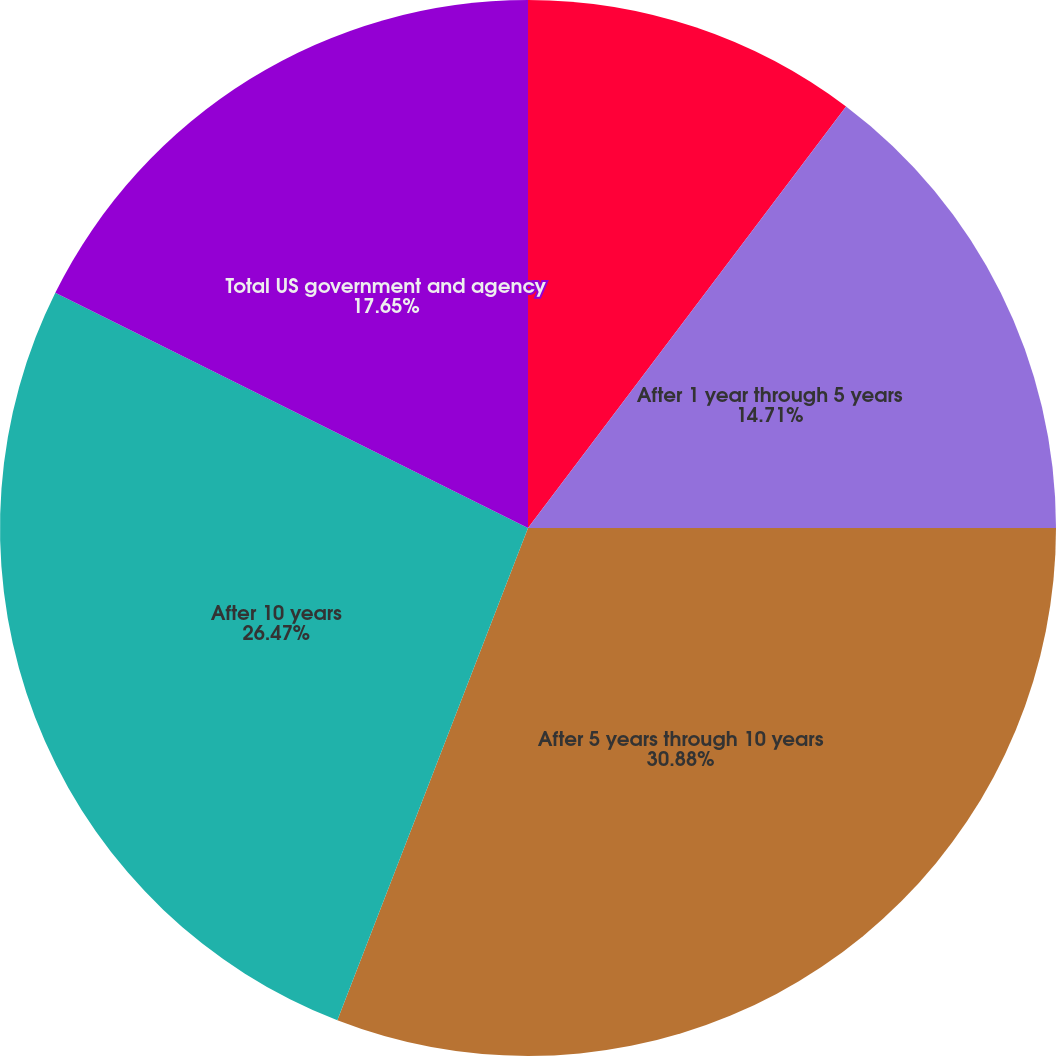Convert chart. <chart><loc_0><loc_0><loc_500><loc_500><pie_chart><fcel>Due within 1 year<fcel>After 1 year through 5 years<fcel>After 5 years through 10 years<fcel>After 10 years<fcel>Total US government and agency<nl><fcel>10.29%<fcel>14.71%<fcel>30.88%<fcel>26.47%<fcel>17.65%<nl></chart> 